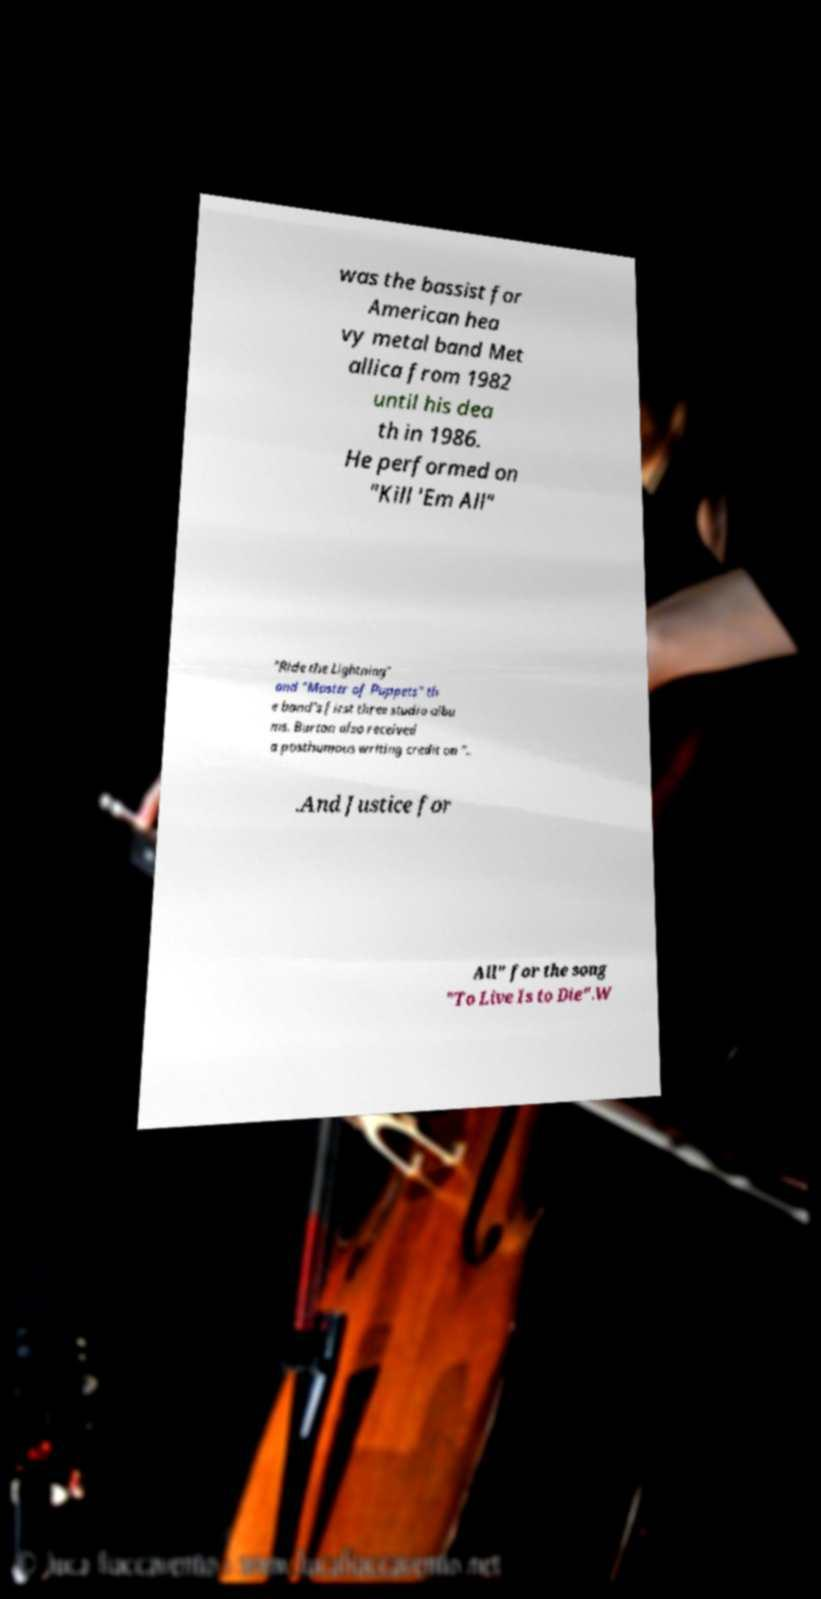Could you assist in decoding the text presented in this image and type it out clearly? was the bassist for American hea vy metal band Met allica from 1982 until his dea th in 1986. He performed on "Kill 'Em All" "Ride the Lightning" and "Master of Puppets" th e band's first three studio albu ms. Burton also received a posthumous writing credit on ".. .And Justice for All" for the song "To Live Is to Die".W 